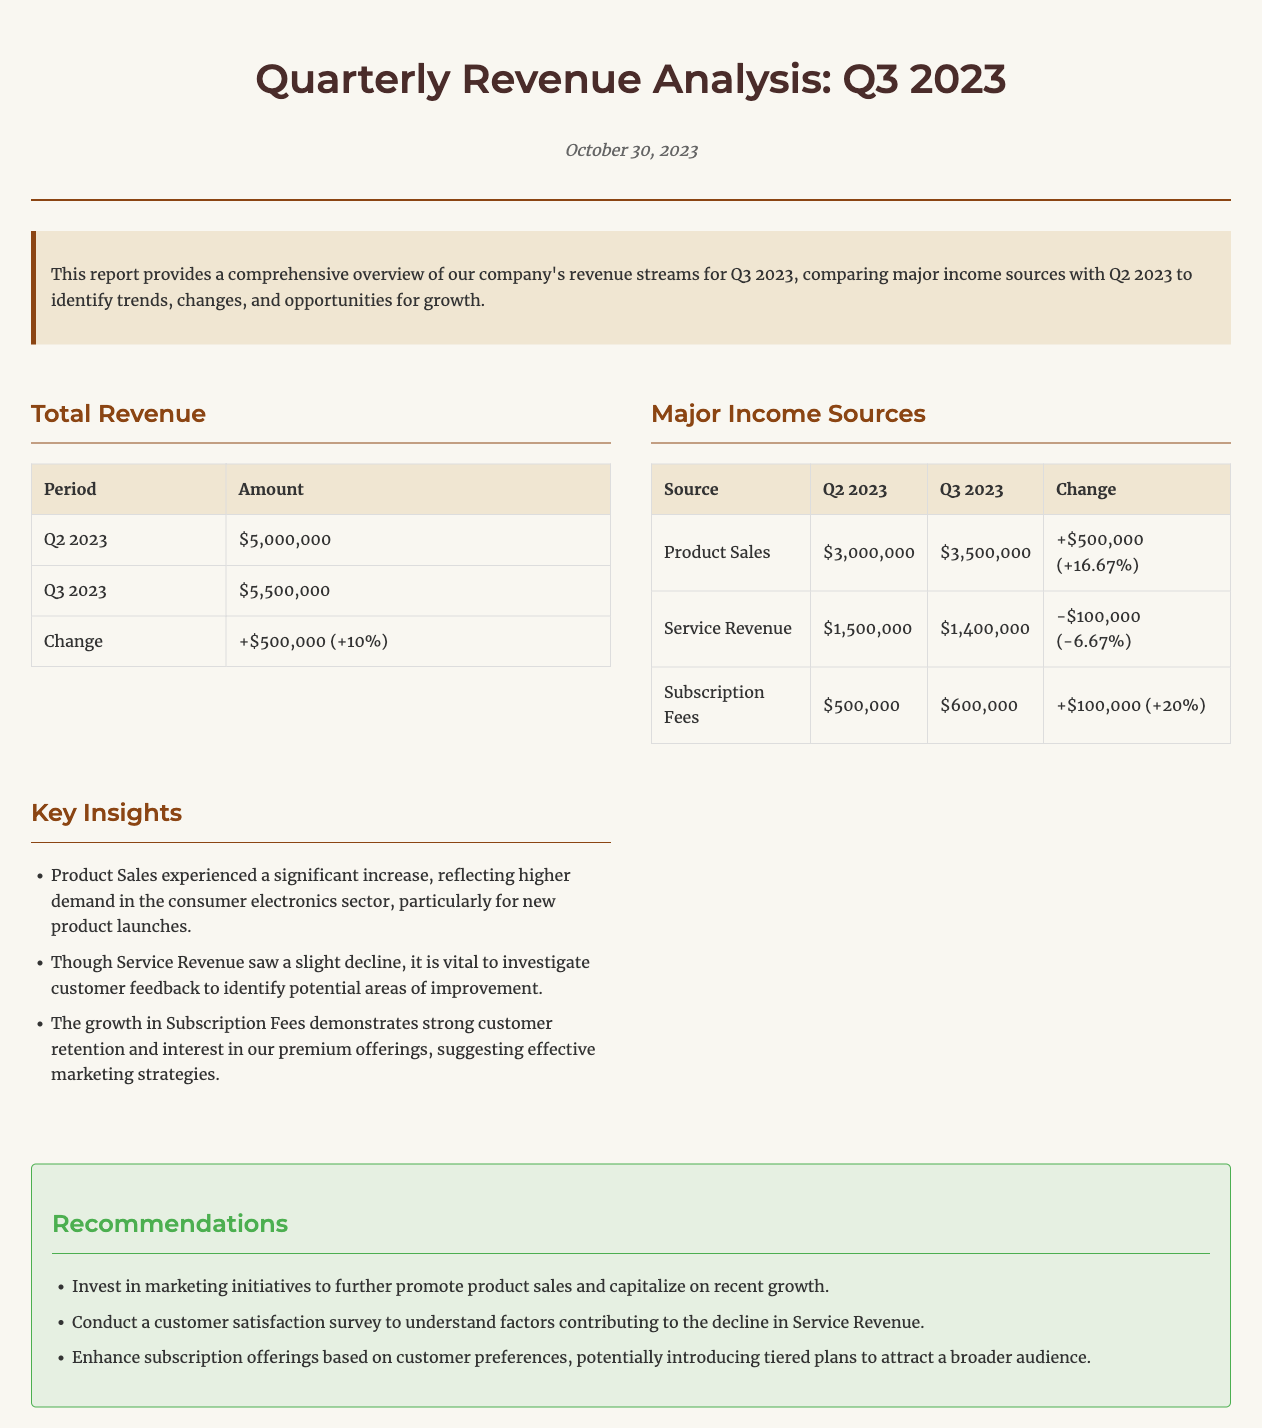What is the total revenue for Q3 2023? The total revenue for Q3 2023 is presented in the document as $5,500,000.
Answer: $5,500,000 What was the change in total revenue from Q2 2023 to Q3 2023? The document states that the change in total revenue is +$500,000 (+10%).
Answer: +$500,000 (+10%) What was the major source of income in Q3 2023? Based on the income sources table, the major source of income in Q3 2023 was Product Sales which amounted to $3,500,000.
Answer: Product Sales By how much did Service Revenue decrease from Q2 2023 to Q3 2023? The document shows that Service Revenue decreased by $100,000 (-6.67%) from Q2 2023 to Q3 2023.
Answer: $100,000 (-6.67%) What are the insights regarding Product Sales? The key insight provided indicates that Product Sales experienced a significant increase due to higher demand in the consumer electronics sector.
Answer: Significant increase What is the reason suggested for the decline in Service Revenue? The document suggests investigating customer feedback to identify potential areas of improvement regarding the decline in Service Revenue.
Answer: Customer feedback What recommendation is made to further promote product sales? One of the recommendations is to invest in marketing initiatives to promote product sales further.
Answer: Invest in marketing initiatives How much did Subscription Fees grow from Q2 2023 to Q3 2023? The income sources table indicates that Subscription Fees grew by $100,000 (+20%) from Q2 2023 to Q3 2023.
Answer: $100,000 (+20%) 